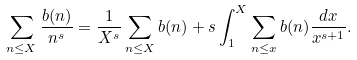<formula> <loc_0><loc_0><loc_500><loc_500>\sum _ { n \leq X } \frac { b ( n ) } { n ^ { s } } = \frac { 1 } { X ^ { s } } \sum _ { n \leq X } b ( n ) + s \int _ { 1 } ^ { X } \sum _ { n \leq x } b ( n ) \frac { d x } { x ^ { s + 1 } } .</formula> 